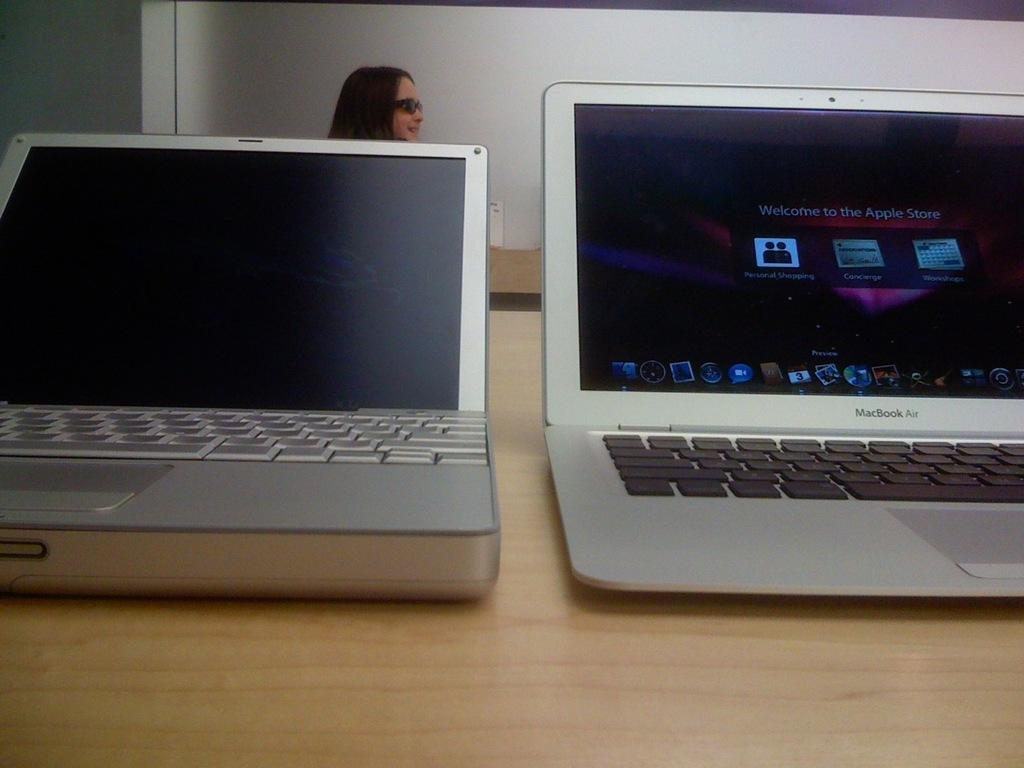<image>
Give a short and clear explanation of the subsequent image. Macbook pro silver laptop with Welcome to the apple store screen. 